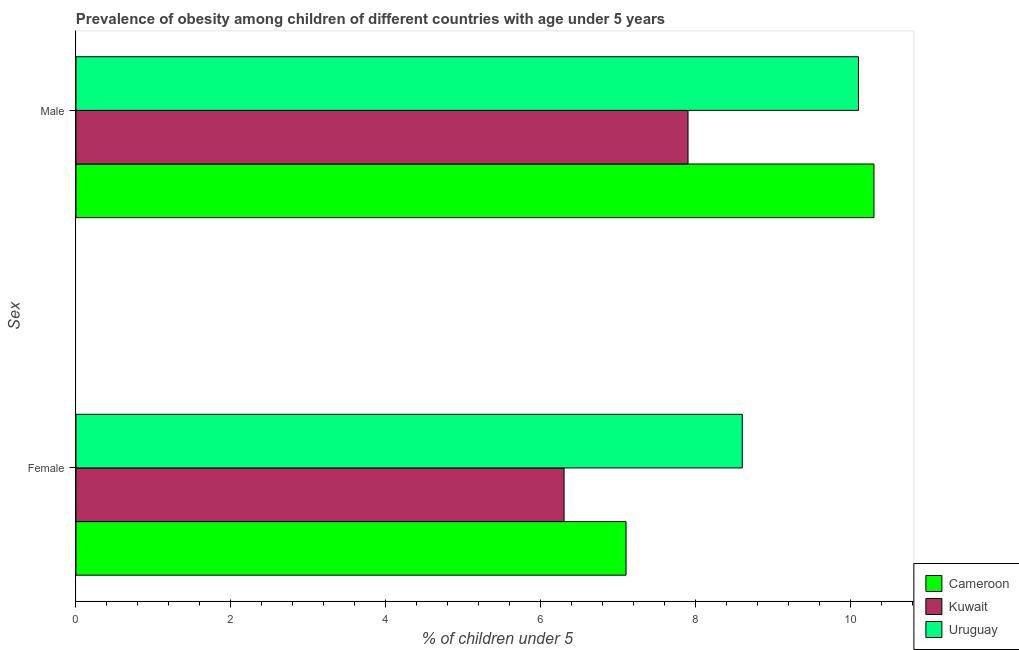How many different coloured bars are there?
Your answer should be very brief. 3. How many groups of bars are there?
Give a very brief answer. 2. How many bars are there on the 1st tick from the top?
Your answer should be compact. 3. How many bars are there on the 1st tick from the bottom?
Your answer should be compact. 3. What is the label of the 1st group of bars from the top?
Provide a short and direct response. Male. What is the percentage of obese female children in Cameroon?
Keep it short and to the point. 7.1. Across all countries, what is the maximum percentage of obese female children?
Your response must be concise. 8.6. Across all countries, what is the minimum percentage of obese female children?
Keep it short and to the point. 6.3. In which country was the percentage of obese male children maximum?
Your answer should be compact. Cameroon. In which country was the percentage of obese female children minimum?
Provide a short and direct response. Kuwait. What is the total percentage of obese female children in the graph?
Your answer should be compact. 22. What is the difference between the percentage of obese male children in Cameroon and that in Uruguay?
Offer a very short reply. 0.2. What is the difference between the percentage of obese female children in Cameroon and the percentage of obese male children in Kuwait?
Ensure brevity in your answer.  -0.8. What is the average percentage of obese male children per country?
Make the answer very short. 9.43. What is the difference between the percentage of obese female children and percentage of obese male children in Cameroon?
Offer a very short reply. -3.2. What is the ratio of the percentage of obese female children in Kuwait to that in Uruguay?
Offer a terse response. 0.73. Is the percentage of obese female children in Cameroon less than that in Kuwait?
Make the answer very short. No. In how many countries, is the percentage of obese female children greater than the average percentage of obese female children taken over all countries?
Provide a short and direct response. 1. What does the 1st bar from the top in Female represents?
Offer a very short reply. Uruguay. What does the 2nd bar from the bottom in Male represents?
Provide a short and direct response. Kuwait. How many bars are there?
Give a very brief answer. 6. Are all the bars in the graph horizontal?
Your answer should be compact. Yes. How many legend labels are there?
Keep it short and to the point. 3. What is the title of the graph?
Give a very brief answer. Prevalence of obesity among children of different countries with age under 5 years. What is the label or title of the X-axis?
Make the answer very short.  % of children under 5. What is the label or title of the Y-axis?
Give a very brief answer. Sex. What is the  % of children under 5 in Cameroon in Female?
Your answer should be very brief. 7.1. What is the  % of children under 5 of Kuwait in Female?
Keep it short and to the point. 6.3. What is the  % of children under 5 in Uruguay in Female?
Keep it short and to the point. 8.6. What is the  % of children under 5 in Cameroon in Male?
Your response must be concise. 10.3. What is the  % of children under 5 of Kuwait in Male?
Keep it short and to the point. 7.9. What is the  % of children under 5 of Uruguay in Male?
Offer a very short reply. 10.1. Across all Sex, what is the maximum  % of children under 5 of Cameroon?
Ensure brevity in your answer.  10.3. Across all Sex, what is the maximum  % of children under 5 in Kuwait?
Your answer should be compact. 7.9. Across all Sex, what is the maximum  % of children under 5 in Uruguay?
Your answer should be compact. 10.1. Across all Sex, what is the minimum  % of children under 5 of Cameroon?
Give a very brief answer. 7.1. Across all Sex, what is the minimum  % of children under 5 of Kuwait?
Your answer should be very brief. 6.3. Across all Sex, what is the minimum  % of children under 5 of Uruguay?
Provide a short and direct response. 8.6. What is the total  % of children under 5 of Cameroon in the graph?
Provide a short and direct response. 17.4. What is the total  % of children under 5 in Kuwait in the graph?
Provide a succinct answer. 14.2. What is the total  % of children under 5 of Uruguay in the graph?
Your answer should be compact. 18.7. What is the difference between the  % of children under 5 of Cameroon in Female and that in Male?
Ensure brevity in your answer.  -3.2. What is the difference between the  % of children under 5 in Kuwait in Female and that in Male?
Your answer should be compact. -1.6. What is the difference between the  % of children under 5 in Uruguay in Female and that in Male?
Give a very brief answer. -1.5. What is the difference between the  % of children under 5 in Cameroon in Female and the  % of children under 5 in Kuwait in Male?
Provide a succinct answer. -0.8. What is the average  % of children under 5 in Cameroon per Sex?
Keep it short and to the point. 8.7. What is the average  % of children under 5 of Uruguay per Sex?
Give a very brief answer. 9.35. What is the difference between the  % of children under 5 of Cameroon and  % of children under 5 of Uruguay in Female?
Make the answer very short. -1.5. What is the difference between the  % of children under 5 in Kuwait and  % of children under 5 in Uruguay in Female?
Provide a succinct answer. -2.3. What is the difference between the  % of children under 5 of Cameroon and  % of children under 5 of Uruguay in Male?
Give a very brief answer. 0.2. What is the difference between the  % of children under 5 in Kuwait and  % of children under 5 in Uruguay in Male?
Offer a terse response. -2.2. What is the ratio of the  % of children under 5 in Cameroon in Female to that in Male?
Offer a terse response. 0.69. What is the ratio of the  % of children under 5 in Kuwait in Female to that in Male?
Keep it short and to the point. 0.8. What is the ratio of the  % of children under 5 of Uruguay in Female to that in Male?
Make the answer very short. 0.85. What is the difference between the highest and the second highest  % of children under 5 of Cameroon?
Make the answer very short. 3.2. What is the difference between the highest and the lowest  % of children under 5 of Cameroon?
Ensure brevity in your answer.  3.2. What is the difference between the highest and the lowest  % of children under 5 in Kuwait?
Give a very brief answer. 1.6. 